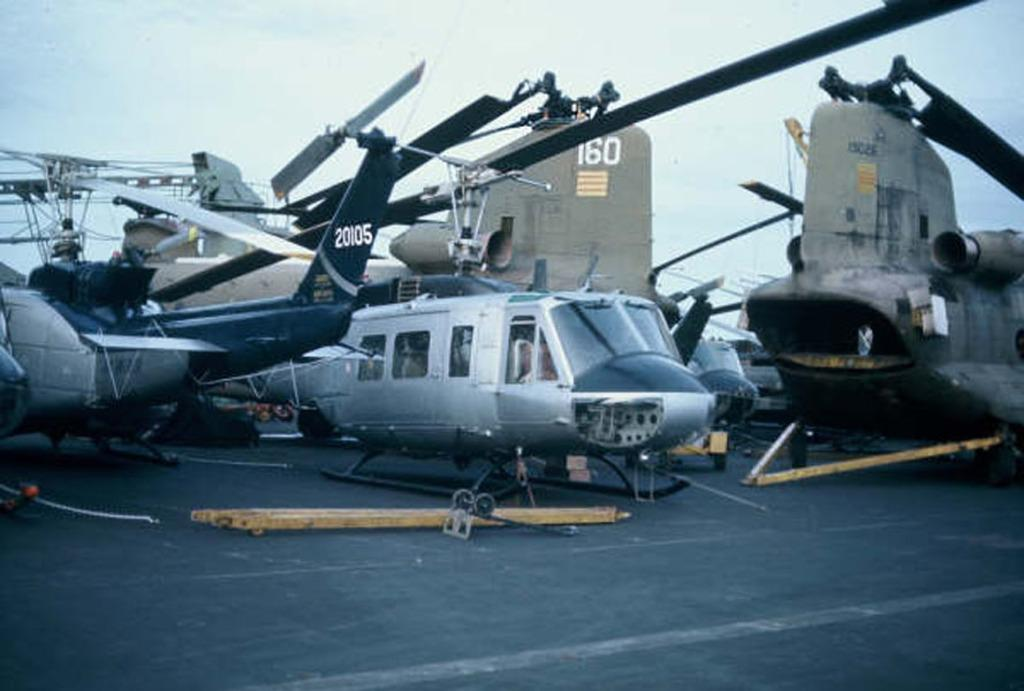<image>
Describe the image concisely. A helicopter on the tarmac has the number 20105 on its tail. 